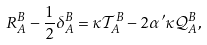Convert formula to latex. <formula><loc_0><loc_0><loc_500><loc_500>R _ { A } ^ { B } - \frac { 1 } { 2 } \delta _ { A } ^ { B } = \kappa { \mathcal { T } } _ { A } ^ { B } - 2 \alpha ^ { \prime } \kappa { \mathcal { Q } } _ { A } ^ { B } ,</formula> 